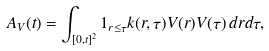Convert formula to latex. <formula><loc_0><loc_0><loc_500><loc_500>A _ { V } ( t ) = \int _ { [ 0 , t ] ^ { 2 } } 1 _ { r \leq \tau } k ( r , \tau ) V ( r ) V ( \tau ) \, d r d \tau ,</formula> 